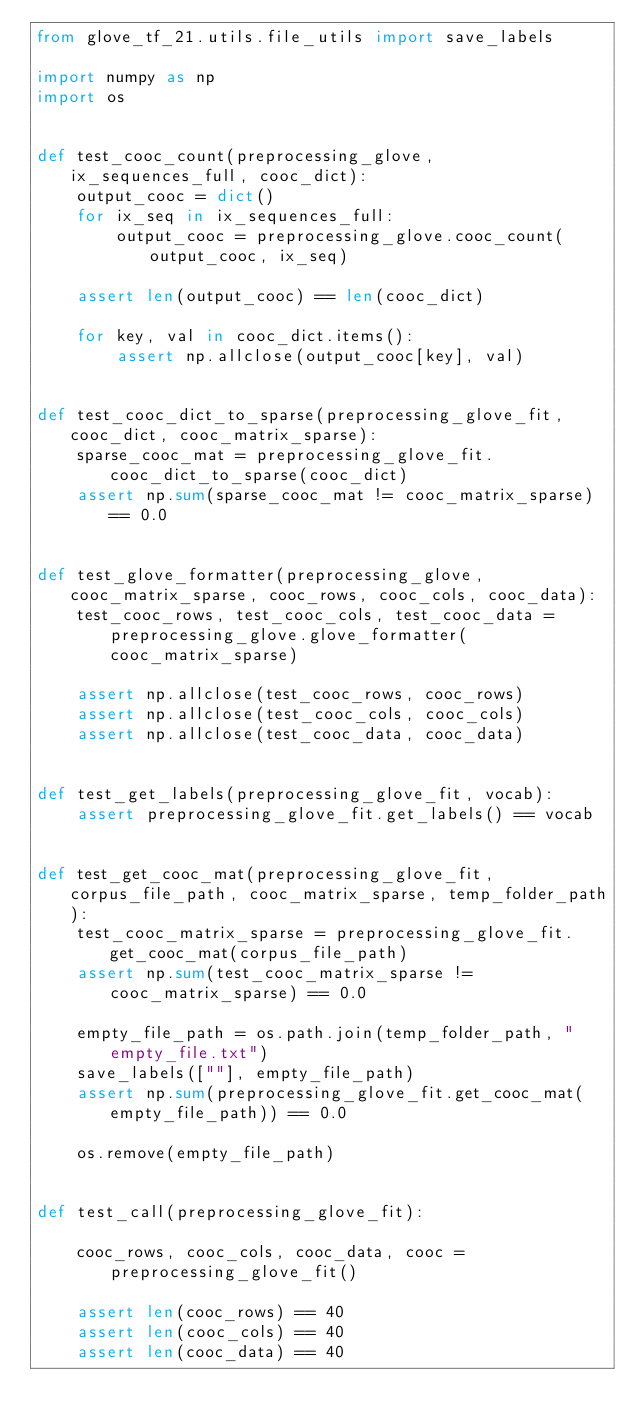Convert code to text. <code><loc_0><loc_0><loc_500><loc_500><_Python_>from glove_tf_21.utils.file_utils import save_labels

import numpy as np
import os


def test_cooc_count(preprocessing_glove, ix_sequences_full, cooc_dict):
    output_cooc = dict()
    for ix_seq in ix_sequences_full:
        output_cooc = preprocessing_glove.cooc_count(output_cooc, ix_seq)

    assert len(output_cooc) == len(cooc_dict)

    for key, val in cooc_dict.items():
        assert np.allclose(output_cooc[key], val)


def test_cooc_dict_to_sparse(preprocessing_glove_fit, cooc_dict, cooc_matrix_sparse):
    sparse_cooc_mat = preprocessing_glove_fit.cooc_dict_to_sparse(cooc_dict)
    assert np.sum(sparse_cooc_mat != cooc_matrix_sparse) == 0.0


def test_glove_formatter(preprocessing_glove, cooc_matrix_sparse, cooc_rows, cooc_cols, cooc_data):
    test_cooc_rows, test_cooc_cols, test_cooc_data = preprocessing_glove.glove_formatter(cooc_matrix_sparse)

    assert np.allclose(test_cooc_rows, cooc_rows)
    assert np.allclose(test_cooc_cols, cooc_cols)
    assert np.allclose(test_cooc_data, cooc_data)


def test_get_labels(preprocessing_glove_fit, vocab):
    assert preprocessing_glove_fit.get_labels() == vocab


def test_get_cooc_mat(preprocessing_glove_fit, corpus_file_path, cooc_matrix_sparse, temp_folder_path):
    test_cooc_matrix_sparse = preprocessing_glove_fit.get_cooc_mat(corpus_file_path)
    assert np.sum(test_cooc_matrix_sparse != cooc_matrix_sparse) == 0.0

    empty_file_path = os.path.join(temp_folder_path, "empty_file.txt")
    save_labels([""], empty_file_path)
    assert np.sum(preprocessing_glove_fit.get_cooc_mat(empty_file_path)) == 0.0

    os.remove(empty_file_path)


def test_call(preprocessing_glove_fit):

    cooc_rows, cooc_cols, cooc_data, cooc = preprocessing_glove_fit()

    assert len(cooc_rows) == 40
    assert len(cooc_cols) == 40
    assert len(cooc_data) == 40
</code> 